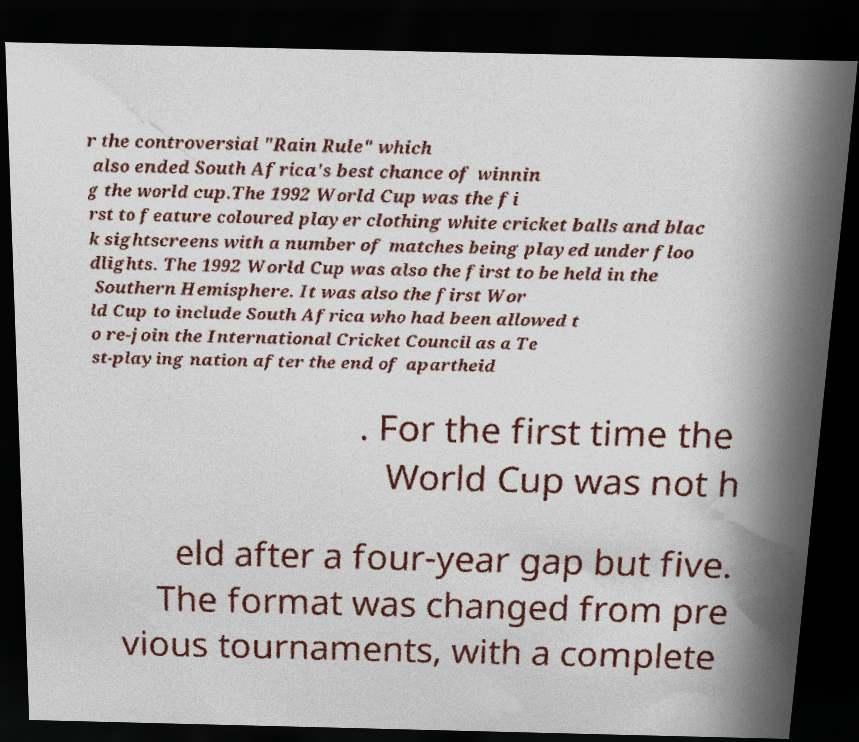Could you extract and type out the text from this image? r the controversial "Rain Rule" which also ended South Africa's best chance of winnin g the world cup.The 1992 World Cup was the fi rst to feature coloured player clothing white cricket balls and blac k sightscreens with a number of matches being played under floo dlights. The 1992 World Cup was also the first to be held in the Southern Hemisphere. It was also the first Wor ld Cup to include South Africa who had been allowed t o re-join the International Cricket Council as a Te st-playing nation after the end of apartheid . For the first time the World Cup was not h eld after a four-year gap but five. The format was changed from pre vious tournaments, with a complete 